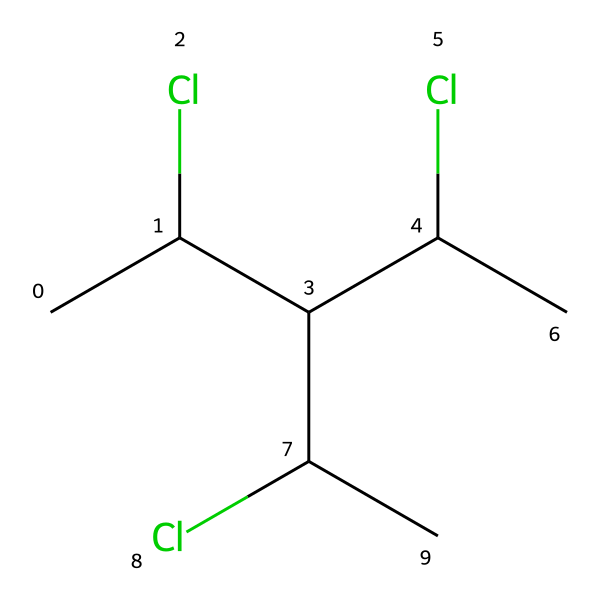What type of halogen is present in the structure? The structure contains chlorine atoms, which are indicated by the "Cl" in the SMILES representation.
Answer: chlorine How many carbon atoms are in this chemical? By analyzing the SMILES representation, we count six "C" characters, indicating there are six carbon atoms in total.
Answer: six How many chlorine substituents are attached to the carbon skeleton? The SMILES shows three "Cl" atoms, indicating three chlorine substituents attached to different carbon atoms within the structure.
Answer: three What is the highest degree of substitution on a carbon atom in this chemical? The carbon atoms in the structure demonstrate varying degrees of substitution, but the most substituted carbon has three chlorine substituents.
Answer: three Is this polymer likely to be resistant to outdoor conditions? The presence of chlorine suggests enhanced chemical resistance, making the polymer likely more durable for outdoor applications.
Answer: yes What type of polymer might this chemical represent? Given the chlorine and carbon backbone, this structure suggests it's a form of chlorinated polymer, often used for durability in materials like signage.
Answer: chlorinated polymer 